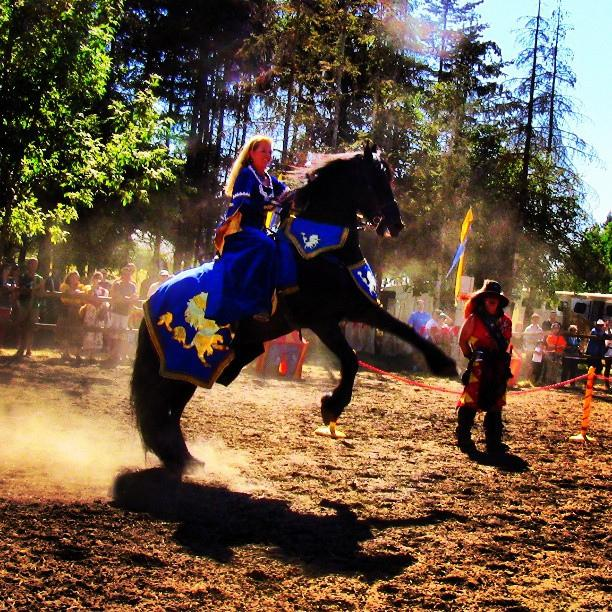What attire is the person standing behind the horse in front of the red rope wearing?

Choices:
A) australian ranger
B) police officer
C) native american
D) latin american native american 